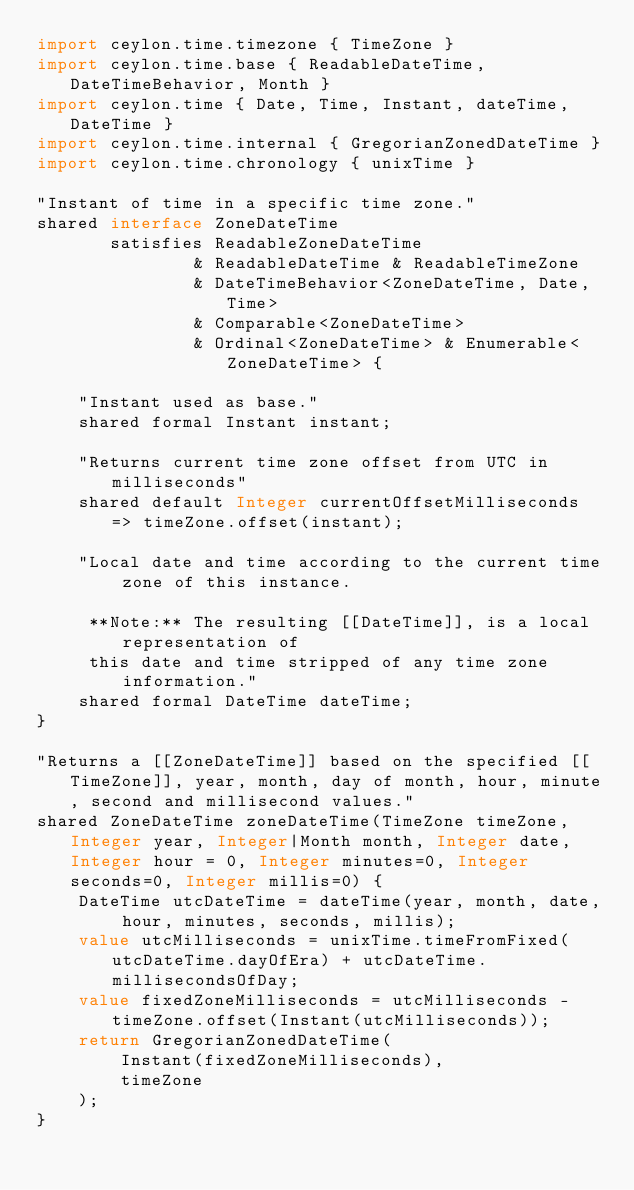Convert code to text. <code><loc_0><loc_0><loc_500><loc_500><_Ceylon_>import ceylon.time.timezone { TimeZone }
import ceylon.time.base { ReadableDateTime, DateTimeBehavior, Month }
import ceylon.time { Date, Time, Instant, dateTime, DateTime }
import ceylon.time.internal { GregorianZonedDateTime }
import ceylon.time.chronology { unixTime }

"Instant of time in a specific time zone."
shared interface ZoneDateTime
       satisfies ReadableZoneDateTime
               & ReadableDateTime & ReadableTimeZone
               & DateTimeBehavior<ZoneDateTime, Date, Time> 
               & Comparable<ZoneDateTime>
               & Ordinal<ZoneDateTime> & Enumerable<ZoneDateTime> {

    "Instant used as base."
    shared formal Instant instant;
    
    "Returns current time zone offset from UTC in milliseconds"
    shared default Integer currentOffsetMilliseconds => timeZone.offset(instant);
    
    "Local date and time according to the current time zone of this instance.
     
     **Note:** The resulting [[DateTime]], is a local representation of 
     this date and time stripped of any time zone information."
    shared formal DateTime dateTime;
}

"Returns a [[ZoneDateTime]] based on the specified [[TimeZone]], year, month, day of month, hour, minute, second and millisecond values."
shared ZoneDateTime zoneDateTime(TimeZone timeZone, Integer year, Integer|Month month, Integer date, Integer hour = 0, Integer minutes=0, Integer seconds=0, Integer millis=0) {
    DateTime utcDateTime = dateTime(year, month, date, hour, minutes, seconds, millis);
    value utcMilliseconds = unixTime.timeFromFixed(utcDateTime.dayOfEra) + utcDateTime.millisecondsOfDay;
    value fixedZoneMilliseconds = utcMilliseconds - timeZone.offset(Instant(utcMilliseconds));
    return GregorianZonedDateTime(
        Instant(fixedZoneMilliseconds),
        timeZone
    );
}
</code> 